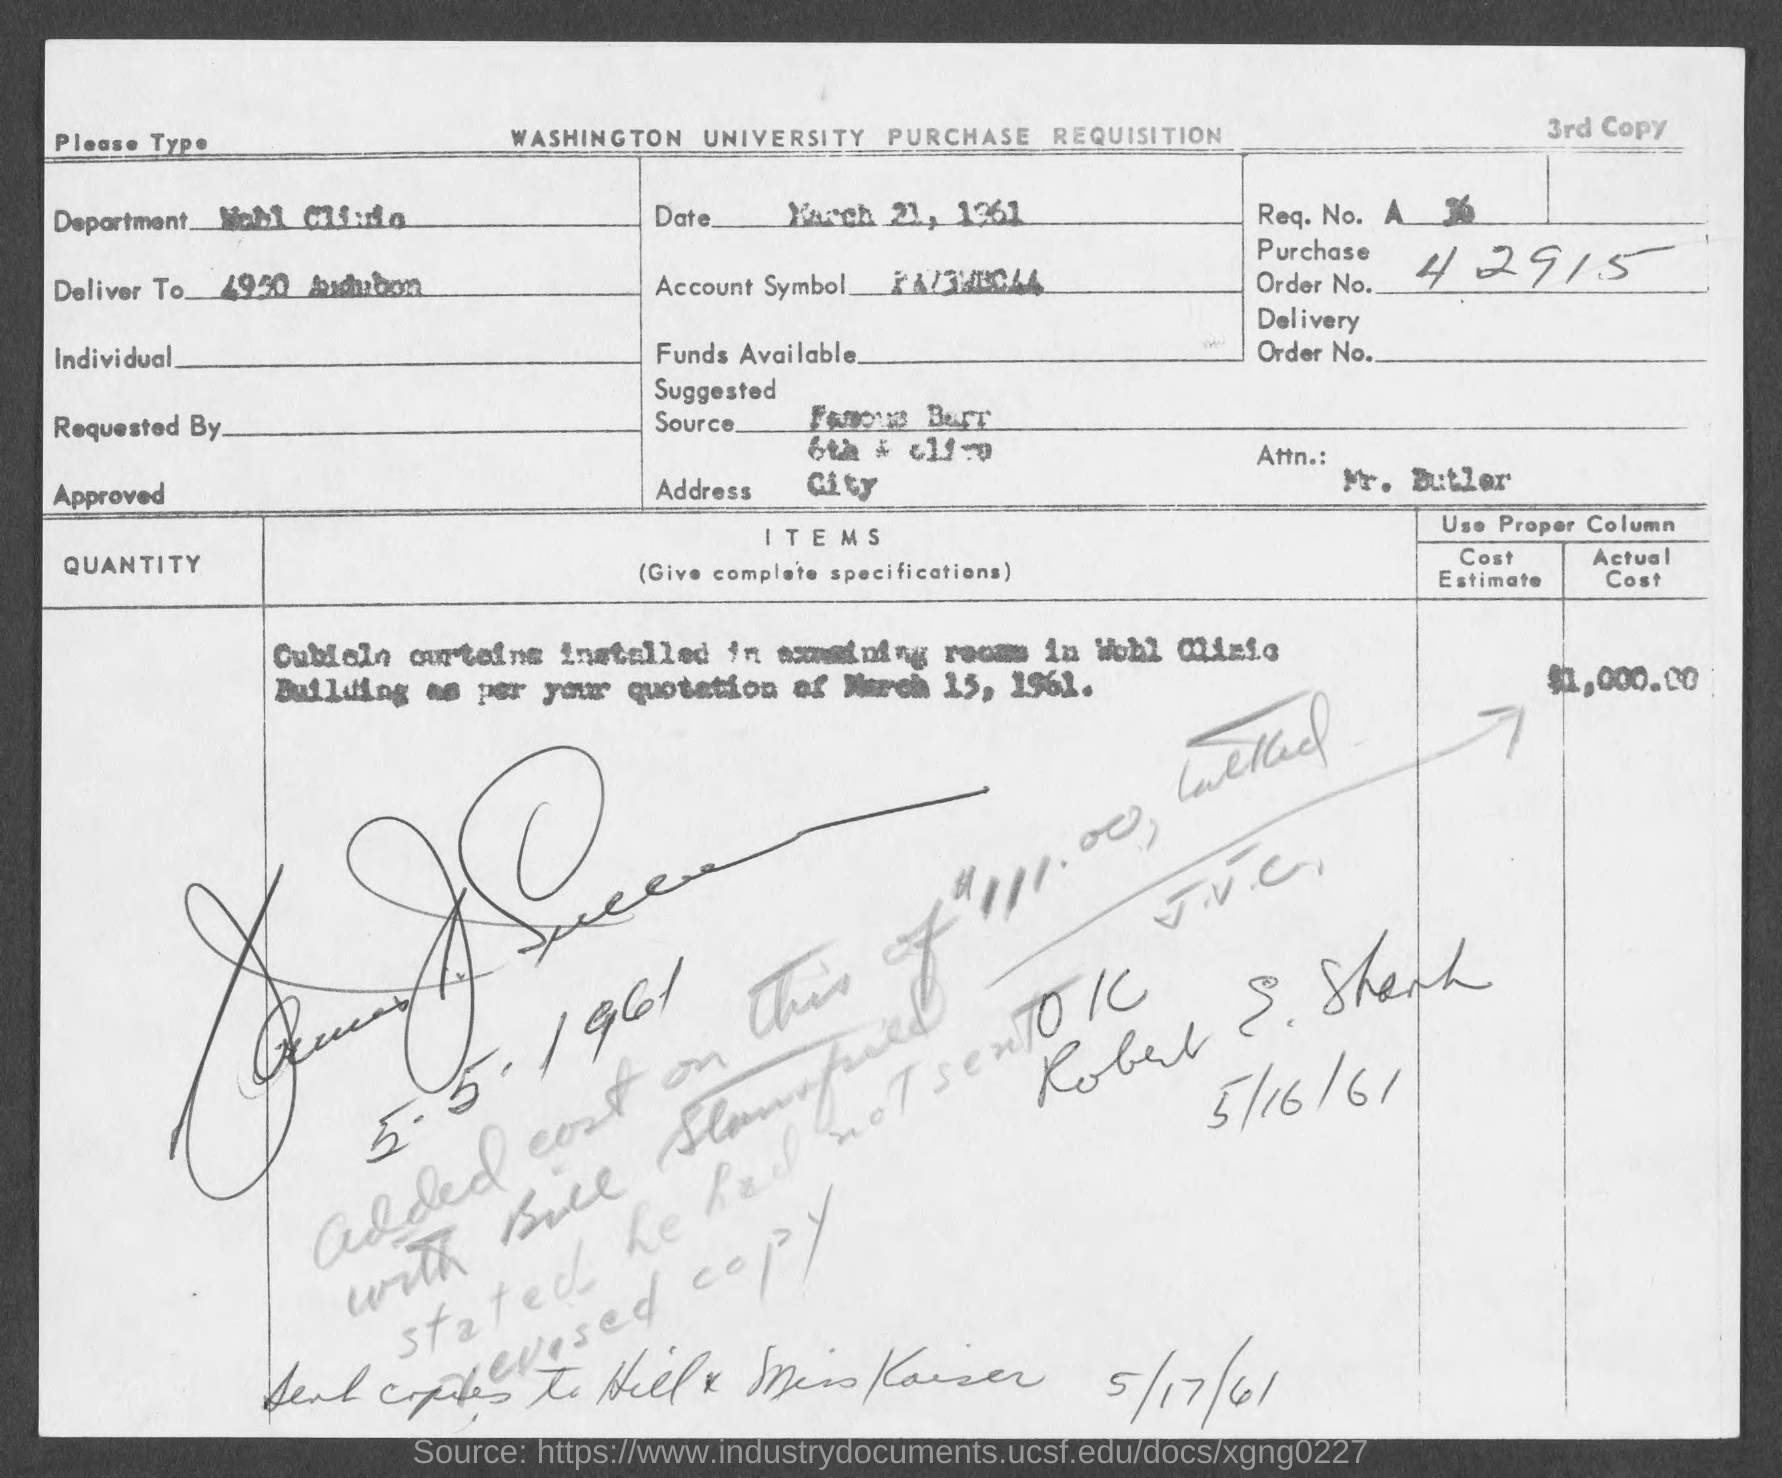What is the purchase order no.?
Provide a succinct answer. 42915. 